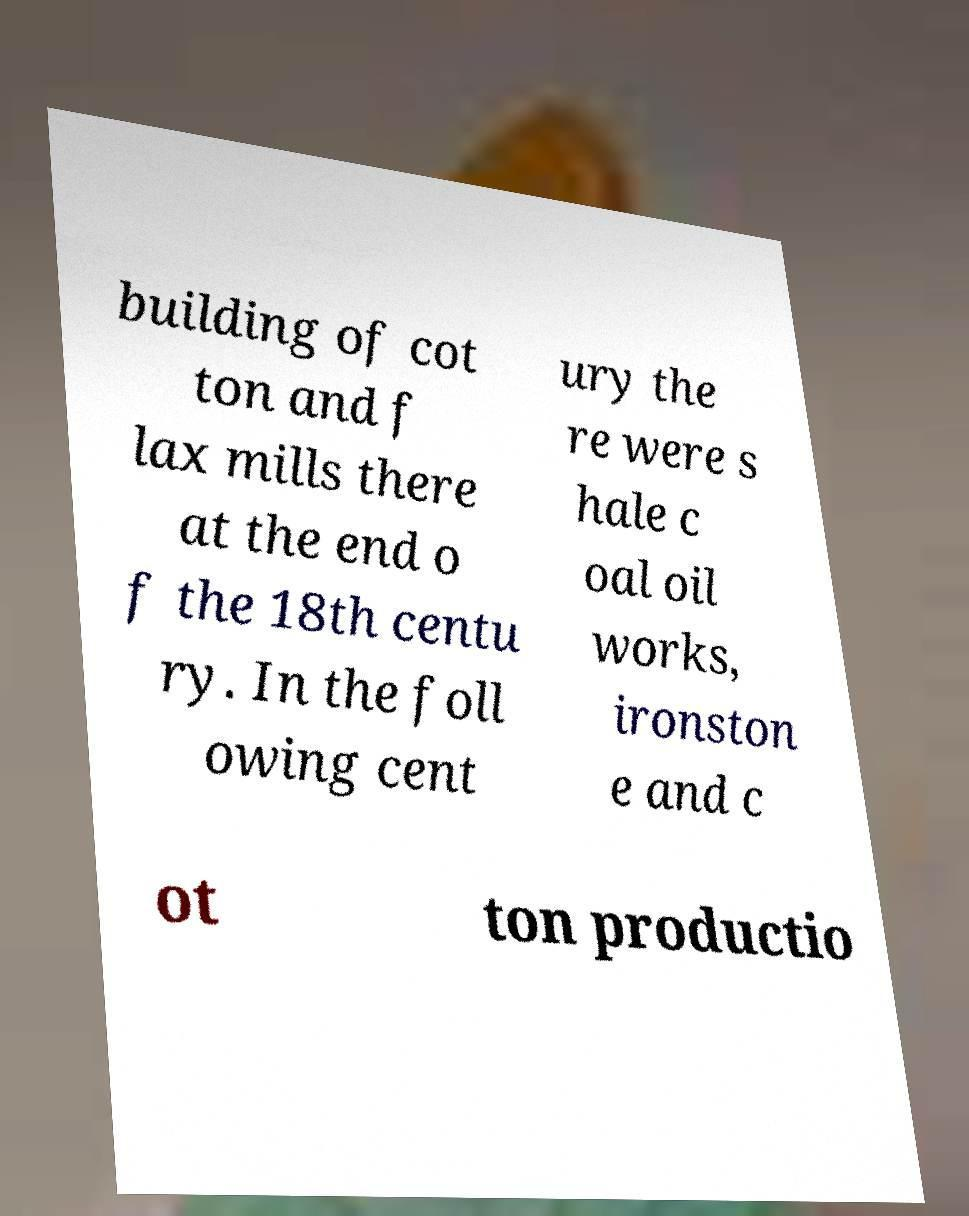Please read and relay the text visible in this image. What does it say? building of cot ton and f lax mills there at the end o f the 18th centu ry. In the foll owing cent ury the re were s hale c oal oil works, ironston e and c ot ton productio 